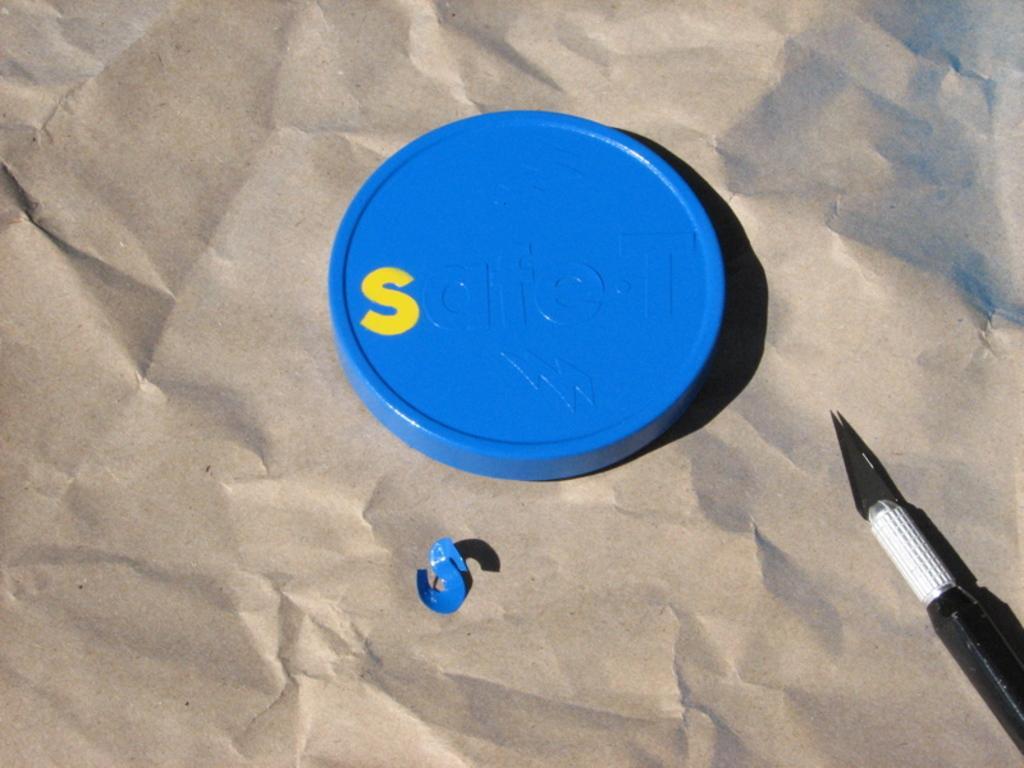Can you describe this image briefly? This image consists of a lid in blue color. At the bottom, there is a paper in brown color. On the right, there is a knife. 